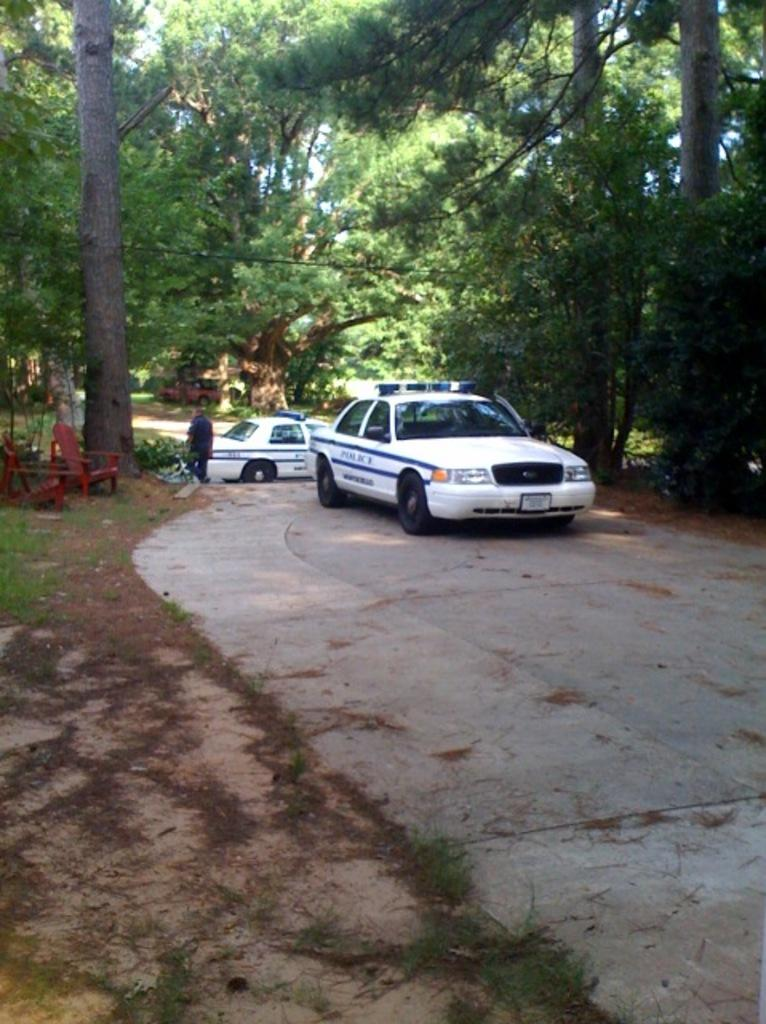What type of vehicles can be seen in the image? There are cars in the image. What type of furniture is present in the image? There are chairs in the image. Can you describe the person in the image? There is a person in the image. What can be seen in the background of the image? There are trees in the background of the image. What type of ground cover is at the bottom of the image? There is grass at the bottom of the image. What type of banana is being used as a manager in the image? There is no banana or manager present in the image. What type of root is growing from the person's head in the image? There is no root growing from the person's head in the image. 